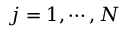Convert formula to latex. <formula><loc_0><loc_0><loc_500><loc_500>{ j = 1 , \cdots , N }</formula> 